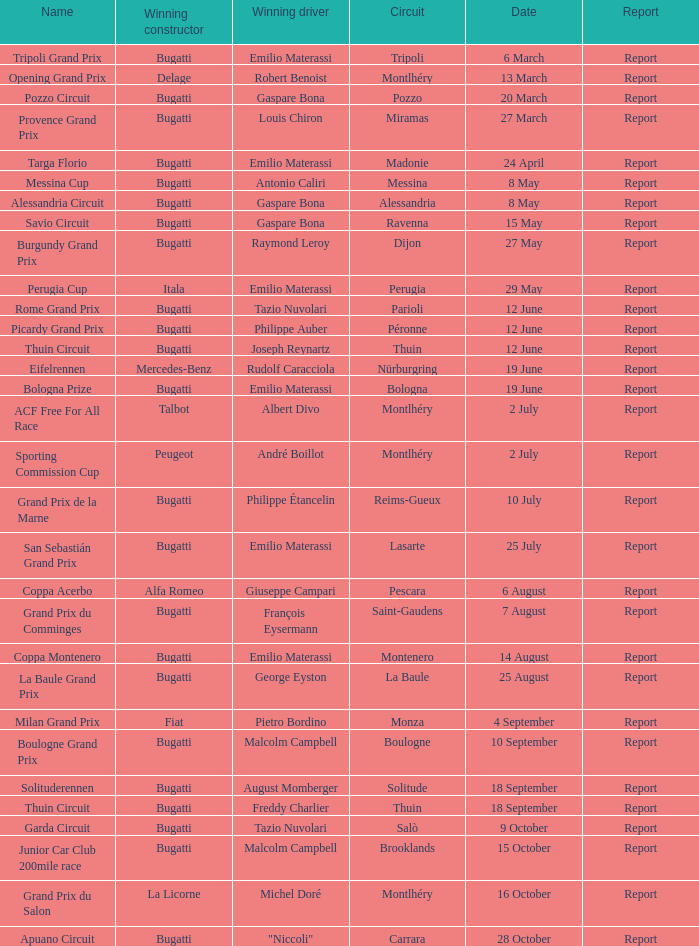Who was the winning constructor at the circuit of parioli? Bugatti. 